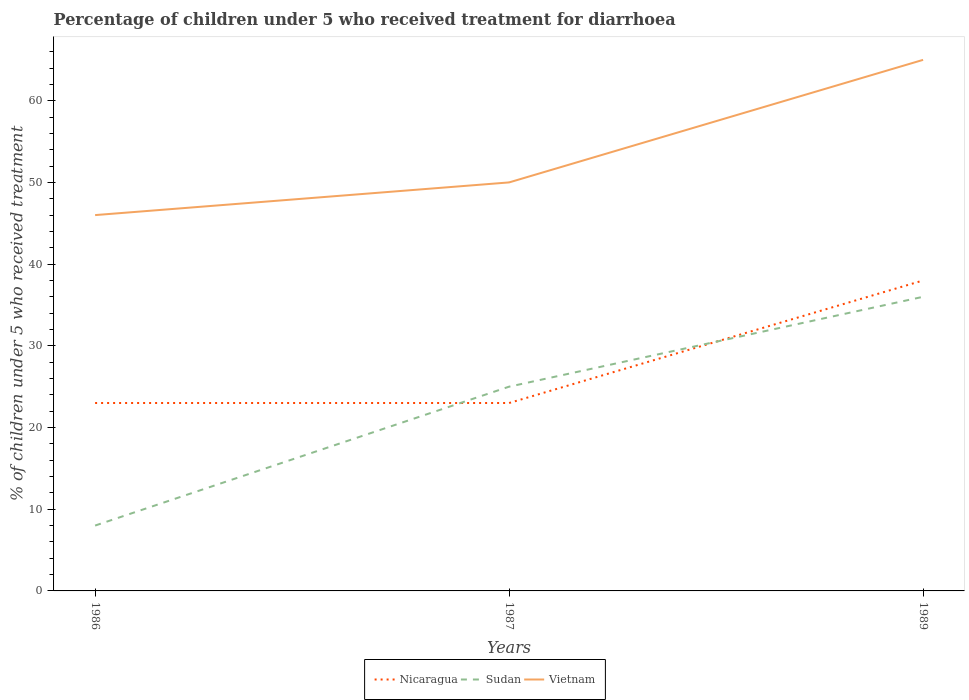Does the line corresponding to Sudan intersect with the line corresponding to Vietnam?
Your answer should be compact. No. Is the number of lines equal to the number of legend labels?
Your response must be concise. Yes. What is the total percentage of children who received treatment for diarrhoea  in Vietnam in the graph?
Make the answer very short. -19. What is the difference between the highest and the second highest percentage of children who received treatment for diarrhoea  in Nicaragua?
Make the answer very short. 15. How many lines are there?
Give a very brief answer. 3. How many years are there in the graph?
Provide a succinct answer. 3. What is the difference between two consecutive major ticks on the Y-axis?
Your response must be concise. 10. Are the values on the major ticks of Y-axis written in scientific E-notation?
Your answer should be very brief. No. How many legend labels are there?
Your response must be concise. 3. What is the title of the graph?
Your response must be concise. Percentage of children under 5 who received treatment for diarrhoea. What is the label or title of the X-axis?
Your answer should be very brief. Years. What is the label or title of the Y-axis?
Ensure brevity in your answer.  % of children under 5 who received treatment. What is the % of children under 5 who received treatment in Sudan in 1986?
Offer a terse response. 8. What is the % of children under 5 who received treatment of Nicaragua in 1987?
Give a very brief answer. 23. What is the % of children under 5 who received treatment of Nicaragua in 1989?
Your answer should be very brief. 38. What is the % of children under 5 who received treatment in Vietnam in 1989?
Your answer should be very brief. 65. Across all years, what is the minimum % of children under 5 who received treatment in Nicaragua?
Your response must be concise. 23. Across all years, what is the minimum % of children under 5 who received treatment of Sudan?
Provide a short and direct response. 8. What is the total % of children under 5 who received treatment of Vietnam in the graph?
Your answer should be compact. 161. What is the difference between the % of children under 5 who received treatment of Vietnam in 1986 and that in 1987?
Provide a succinct answer. -4. What is the difference between the % of children under 5 who received treatment in Sudan in 1986 and that in 1989?
Your answer should be compact. -28. What is the difference between the % of children under 5 who received treatment in Nicaragua in 1987 and that in 1989?
Provide a succinct answer. -15. What is the difference between the % of children under 5 who received treatment of Nicaragua in 1986 and the % of children under 5 who received treatment of Vietnam in 1987?
Offer a very short reply. -27. What is the difference between the % of children under 5 who received treatment in Sudan in 1986 and the % of children under 5 who received treatment in Vietnam in 1987?
Offer a terse response. -42. What is the difference between the % of children under 5 who received treatment of Nicaragua in 1986 and the % of children under 5 who received treatment of Vietnam in 1989?
Keep it short and to the point. -42. What is the difference between the % of children under 5 who received treatment in Sudan in 1986 and the % of children under 5 who received treatment in Vietnam in 1989?
Give a very brief answer. -57. What is the difference between the % of children under 5 who received treatment in Nicaragua in 1987 and the % of children under 5 who received treatment in Sudan in 1989?
Give a very brief answer. -13. What is the difference between the % of children under 5 who received treatment in Nicaragua in 1987 and the % of children under 5 who received treatment in Vietnam in 1989?
Your answer should be very brief. -42. What is the average % of children under 5 who received treatment in Sudan per year?
Give a very brief answer. 23. What is the average % of children under 5 who received treatment of Vietnam per year?
Provide a succinct answer. 53.67. In the year 1986, what is the difference between the % of children under 5 who received treatment of Nicaragua and % of children under 5 who received treatment of Sudan?
Provide a short and direct response. 15. In the year 1986, what is the difference between the % of children under 5 who received treatment of Nicaragua and % of children under 5 who received treatment of Vietnam?
Your answer should be very brief. -23. In the year 1986, what is the difference between the % of children under 5 who received treatment of Sudan and % of children under 5 who received treatment of Vietnam?
Keep it short and to the point. -38. In the year 1987, what is the difference between the % of children under 5 who received treatment in Nicaragua and % of children under 5 who received treatment in Vietnam?
Offer a terse response. -27. In the year 1987, what is the difference between the % of children under 5 who received treatment of Sudan and % of children under 5 who received treatment of Vietnam?
Ensure brevity in your answer.  -25. In the year 1989, what is the difference between the % of children under 5 who received treatment of Sudan and % of children under 5 who received treatment of Vietnam?
Your answer should be very brief. -29. What is the ratio of the % of children under 5 who received treatment in Sudan in 1986 to that in 1987?
Ensure brevity in your answer.  0.32. What is the ratio of the % of children under 5 who received treatment in Nicaragua in 1986 to that in 1989?
Keep it short and to the point. 0.61. What is the ratio of the % of children under 5 who received treatment in Sudan in 1986 to that in 1989?
Offer a very short reply. 0.22. What is the ratio of the % of children under 5 who received treatment in Vietnam in 1986 to that in 1989?
Make the answer very short. 0.71. What is the ratio of the % of children under 5 who received treatment in Nicaragua in 1987 to that in 1989?
Offer a terse response. 0.61. What is the ratio of the % of children under 5 who received treatment of Sudan in 1987 to that in 1989?
Provide a short and direct response. 0.69. What is the ratio of the % of children under 5 who received treatment in Vietnam in 1987 to that in 1989?
Your answer should be compact. 0.77. What is the difference between the highest and the second highest % of children under 5 who received treatment in Vietnam?
Provide a succinct answer. 15. What is the difference between the highest and the lowest % of children under 5 who received treatment of Nicaragua?
Your answer should be very brief. 15. What is the difference between the highest and the lowest % of children under 5 who received treatment in Sudan?
Give a very brief answer. 28. 